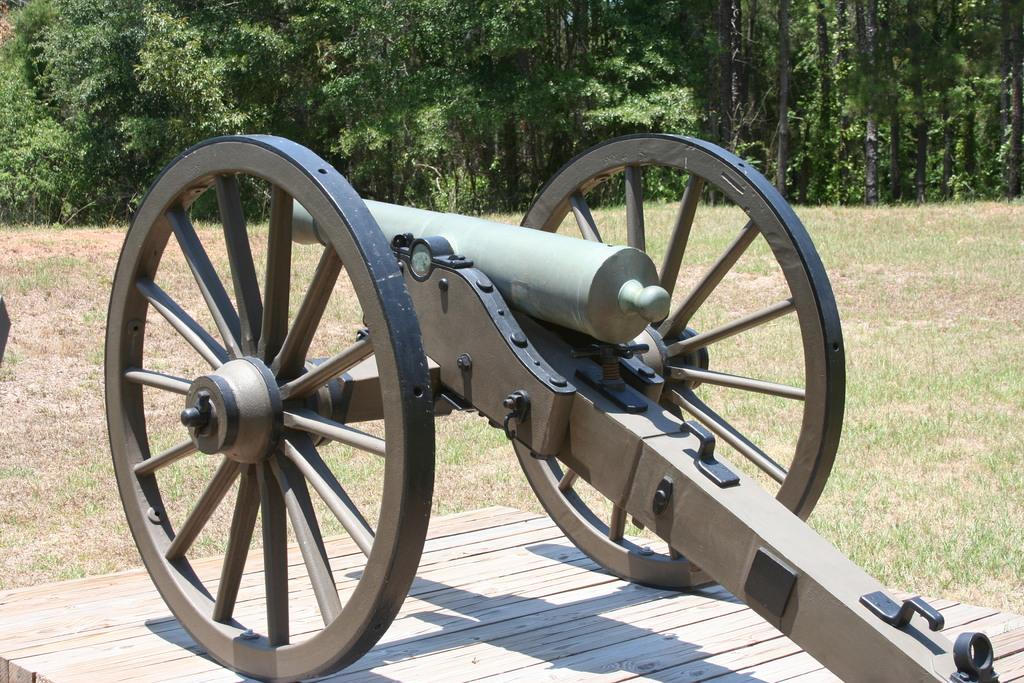What is the main object in the middle of the image? There is a cannon in the middle of the image. What can be seen in the background of the image? There are trees in the background of the image. What type of surface is at the bottom of the image? There is a wooden floor at the bottom of the image. Where is the cannon placed in relation to the wooden floor? The cannon is placed on the wooden floor. Is there a lamp attached to the cannon in the image? No, there is no lamp attached to the cannon in the image. 